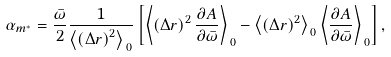<formula> <loc_0><loc_0><loc_500><loc_500>\alpha _ { m ^ { * } } = \frac { \bar { \omega } } { 2 } \frac { 1 } { \left \langle \left ( \Delta { r } \right ) ^ { 2 } \right \rangle _ { \, 0 } } \left [ \left \langle \left ( \Delta { r } \right ) ^ { 2 } \frac { \partial A } { \partial \bar { \omega } } \right \rangle _ { \, 0 } - \left \langle \left ( \Delta { r } \right ) ^ { 2 } \right \rangle _ { \, 0 } \left \langle \frac { \partial A } { \partial \bar { \omega } } \right \rangle _ { \, 0 } \right ] ,</formula> 